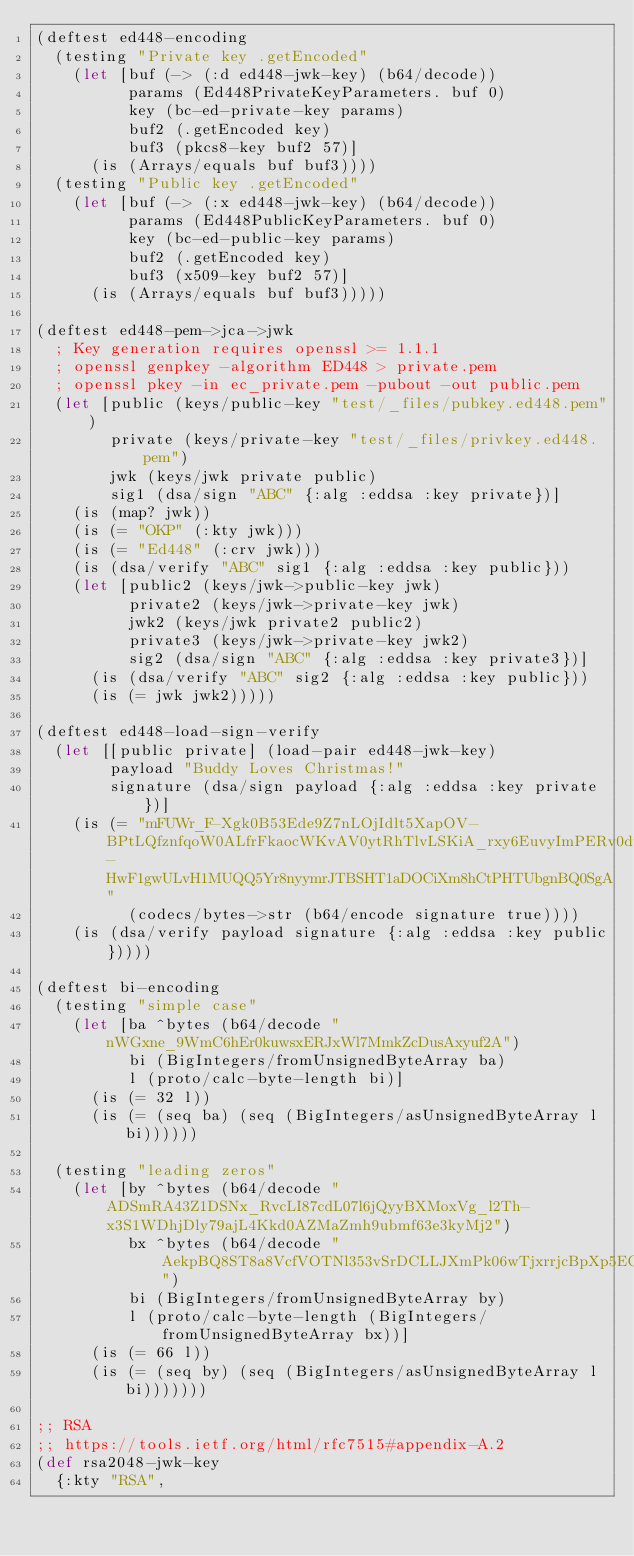Convert code to text. <code><loc_0><loc_0><loc_500><loc_500><_Clojure_>(deftest ed448-encoding
  (testing "Private key .getEncoded"
    (let [buf (-> (:d ed448-jwk-key) (b64/decode))
          params (Ed448PrivateKeyParameters. buf 0)
          key (bc-ed-private-key params)
          buf2 (.getEncoded key)
          buf3 (pkcs8-key buf2 57)]
      (is (Arrays/equals buf buf3))))
  (testing "Public key .getEncoded"
    (let [buf (-> (:x ed448-jwk-key) (b64/decode))
          params (Ed448PublicKeyParameters. buf 0)
          key (bc-ed-public-key params)
          buf2 (.getEncoded key)
          buf3 (x509-key buf2 57)]
      (is (Arrays/equals buf buf3)))))

(deftest ed448-pem->jca->jwk
  ; Key generation requires openssl >= 1.1.1
  ; openssl genpkey -algorithm ED448 > private.pem
  ; openssl pkey -in ec_private.pem -pubout -out public.pem
  (let [public (keys/public-key "test/_files/pubkey.ed448.pem")
        private (keys/private-key "test/_files/privkey.ed448.pem")
        jwk (keys/jwk private public)
        sig1 (dsa/sign "ABC" {:alg :eddsa :key private})]
    (is (map? jwk))
    (is (= "OKP" (:kty jwk)))
    (is (= "Ed448" (:crv jwk)))
    (is (dsa/verify "ABC" sig1 {:alg :eddsa :key public}))
    (let [public2 (keys/jwk->public-key jwk)
          private2 (keys/jwk->private-key jwk)
          jwk2 (keys/jwk private2 public2)
          private3 (keys/jwk->private-key jwk2)
          sig2 (dsa/sign "ABC" {:alg :eddsa :key private3})]
      (is (dsa/verify "ABC" sig2 {:alg :eddsa :key public}))
      (is (= jwk jwk2)))))

(deftest ed448-load-sign-verify
  (let [[public private] (load-pair ed448-jwk-key)
        payload "Buddy Loves Christmas!"
        signature (dsa/sign payload {:alg :eddsa :key private})]
    (is (= "mFUWr_F-Xgk0B53Ede9Z7nLOjIdlt5XapOV-BPtLQfznfqoW0ALfrFkaocWKvAV0ytRhTlvLSKiA_rxy6EuvyImPERv0duTf-HwF1gwULvH1MUQQ5Yr8nyymrJTBSHT1aDOCiXm8hCtPHTUbgnBQ0SgA"
          (codecs/bytes->str (b64/encode signature true))))
    (is (dsa/verify payload signature {:alg :eddsa :key public}))))

(deftest bi-encoding
  (testing "simple case"
    (let [ba ^bytes (b64/decode "nWGxne_9WmC6hEr0kuwsxERJxWl7MmkZcDusAxyuf2A")
          bi (BigIntegers/fromUnsignedByteArray ba)
          l (proto/calc-byte-length bi)]
      (is (= 32 l))
      (is (= (seq ba) (seq (BigIntegers/asUnsignedByteArray l bi))))))

  (testing "leading zeros"
    (let [by ^bytes (b64/decode "ADSmRA43Z1DSNx_RvcLI87cdL07l6jQyyBXMoxVg_l2Th-x3S1WDhjDly79ajL4Kkd0AZMaZmh9ubmf63e3kyMj2")
          bx ^bytes (b64/decode "AekpBQ8ST8a8VcfVOTNl353vSrDCLLJXmPk06wTjxrrjcBpXp5EOnYG_NjFZ6OvLFV1jSfS9tsz4qUxcWceqwQGk")
          bi (BigIntegers/fromUnsignedByteArray by)
          l (proto/calc-byte-length (BigIntegers/fromUnsignedByteArray bx))]
      (is (= 66 l))
      (is (= (seq by) (seq (BigIntegers/asUnsignedByteArray l bi)))))))

;; RSA
;; https://tools.ietf.org/html/rfc7515#appendix-A.2
(def rsa2048-jwk-key
  {:kty "RSA",</code> 